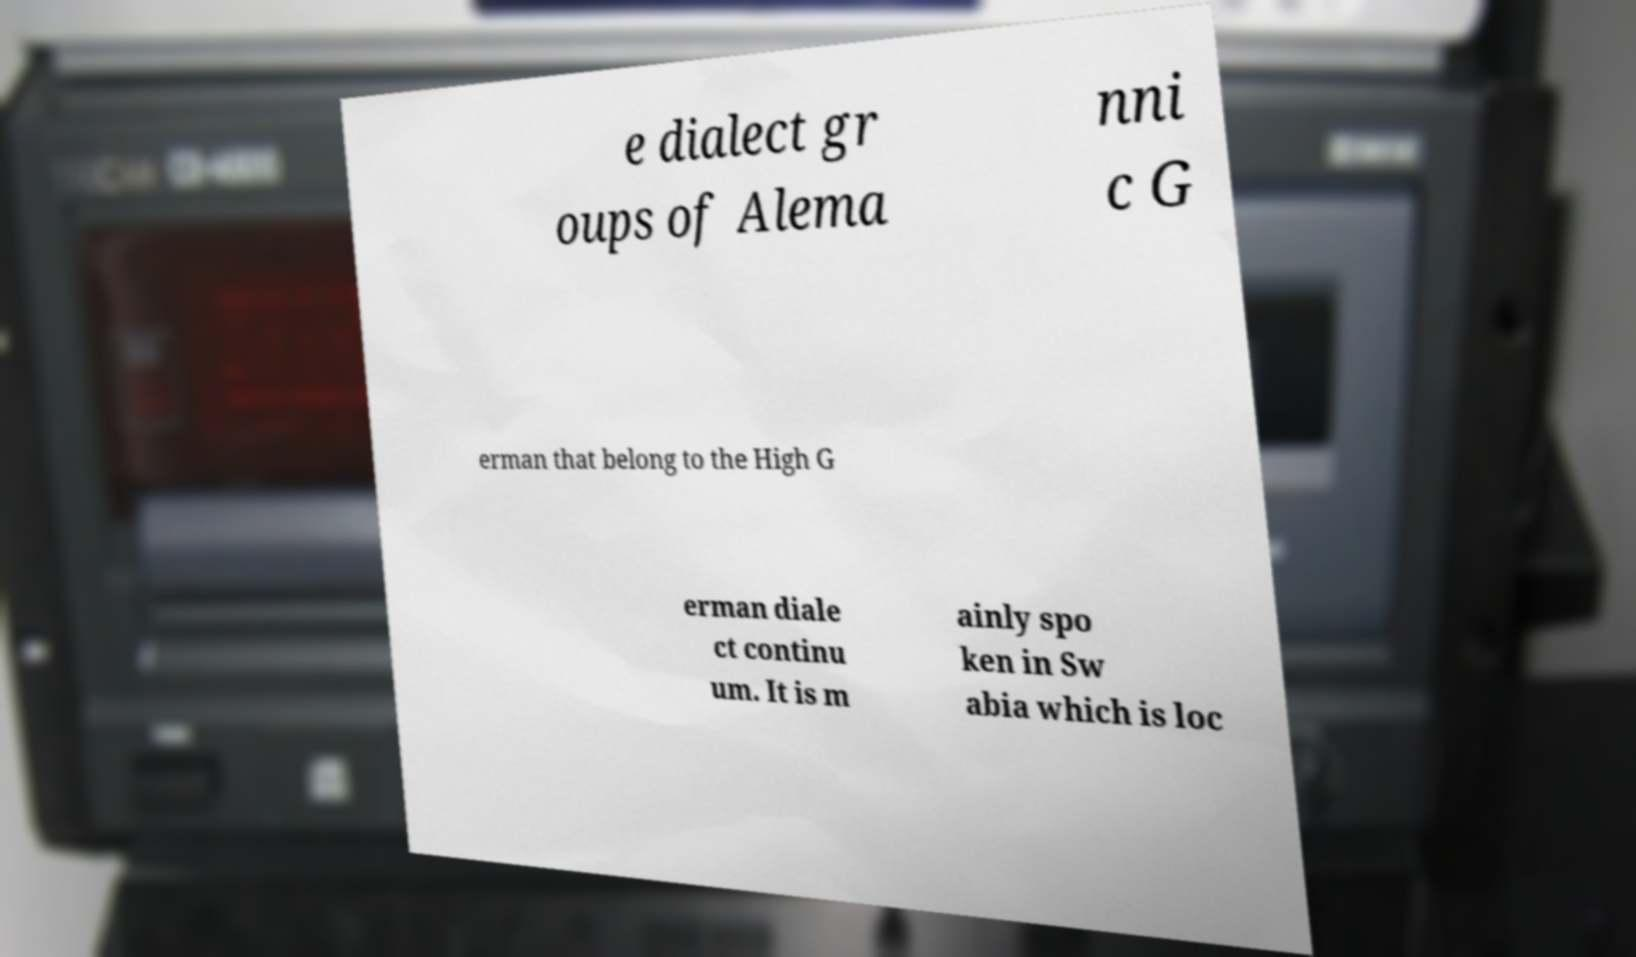I need the written content from this picture converted into text. Can you do that? e dialect gr oups of Alema nni c G erman that belong to the High G erman diale ct continu um. It is m ainly spo ken in Sw abia which is loc 